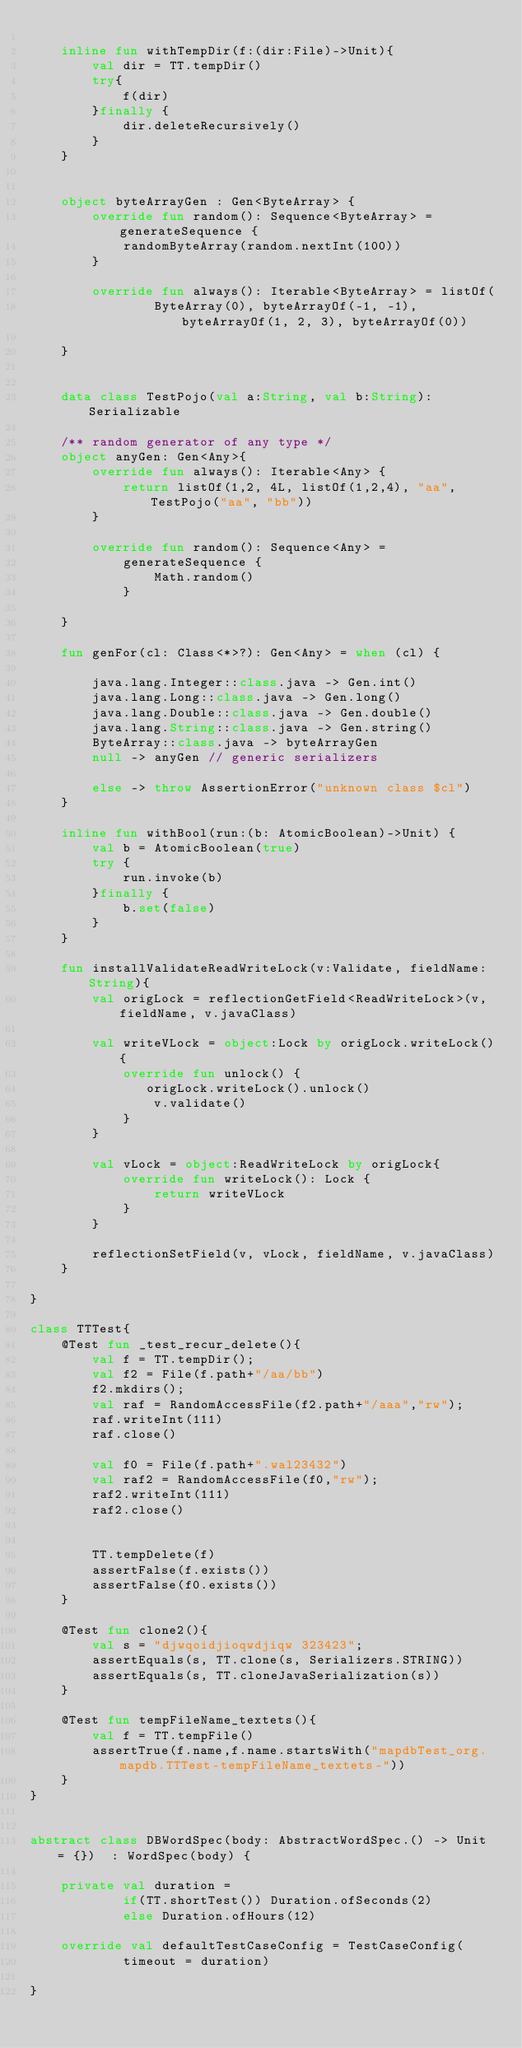<code> <loc_0><loc_0><loc_500><loc_500><_Kotlin_>
    inline fun withTempDir(f:(dir:File)->Unit){
        val dir = TT.tempDir()
        try{
            f(dir)
        }finally {
            dir.deleteRecursively()
        }
    }


    object byteArrayGen : Gen<ByteArray> {
        override fun random(): Sequence<ByteArray> = generateSequence {
            randomByteArray(random.nextInt(100))
        }

        override fun always(): Iterable<ByteArray> = listOf(
                ByteArray(0), byteArrayOf(-1, -1), byteArrayOf(1, 2, 3), byteArrayOf(0))

    }


    data class TestPojo(val a:String, val b:String):Serializable

    /** random generator of any type */
    object anyGen: Gen<Any>{
        override fun always(): Iterable<Any> {
            return listOf(1,2, 4L, listOf(1,2,4), "aa", TestPojo("aa", "bb"))
        }

        override fun random(): Sequence<Any> =
            generateSequence {
                Math.random()
            }

    }

    fun genFor(cl: Class<*>?): Gen<Any> = when (cl) {

        java.lang.Integer::class.java -> Gen.int()
        java.lang.Long::class.java -> Gen.long()
        java.lang.Double::class.java -> Gen.double()
        java.lang.String::class.java -> Gen.string()
        ByteArray::class.java -> byteArrayGen
        null -> anyGen // generic serializers

        else -> throw AssertionError("unknown class $cl")
    }

    inline fun withBool(run:(b: AtomicBoolean)->Unit) {
        val b = AtomicBoolean(true)
        try {
            run.invoke(b)
        }finally {
            b.set(false)
        }
    }

    fun installValidateReadWriteLock(v:Validate, fieldName:String){
        val origLock = reflectionGetField<ReadWriteLock>(v, fieldName, v.javaClass)

        val writeVLock = object:Lock by origLock.writeLock(){
            override fun unlock() {
               origLock.writeLock().unlock()
                v.validate()
            }
        }

        val vLock = object:ReadWriteLock by origLock{
            override fun writeLock(): Lock {
                return writeVLock
            }
        }

        reflectionSetField(v, vLock, fieldName, v.javaClass)
    }

}

class TTTest{
    @Test fun _test_recur_delete(){
        val f = TT.tempDir();
        val f2 = File(f.path+"/aa/bb")
        f2.mkdirs();
        val raf = RandomAccessFile(f2.path+"/aaa","rw");
        raf.writeInt(111)
        raf.close()

        val f0 = File(f.path+".wal23432")
        val raf2 = RandomAccessFile(f0,"rw");
        raf2.writeInt(111)
        raf2.close()


        TT.tempDelete(f)
        assertFalse(f.exists())
        assertFalse(f0.exists())
    }

    @Test fun clone2(){
        val s = "djwqoidjioqwdjiqw 323423";
        assertEquals(s, TT.clone(s, Serializers.STRING))
        assertEquals(s, TT.cloneJavaSerialization(s))
    }

    @Test fun tempFileName_textets(){
        val f = TT.tempFile()
        assertTrue(f.name,f.name.startsWith("mapdbTest_org.mapdb.TTTest-tempFileName_textets-"))
    }
}


abstract class DBWordSpec(body: AbstractWordSpec.() -> Unit = {})  : WordSpec(body) {

    private val duration =
            if(TT.shortTest()) Duration.ofSeconds(2)
            else Duration.ofHours(12)

    override val defaultTestCaseConfig = TestCaseConfig(
            timeout = duration)

}</code> 